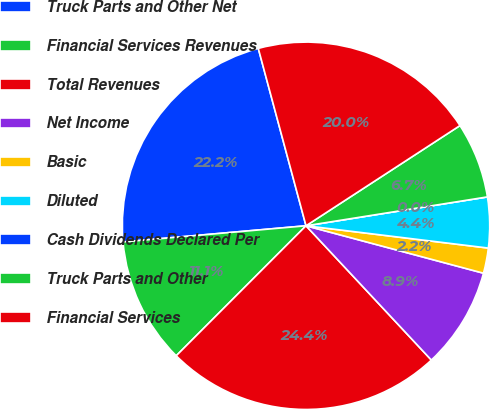Convert chart to OTSL. <chart><loc_0><loc_0><loc_500><loc_500><pie_chart><fcel>Truck Parts and Other Net<fcel>Financial Services Revenues<fcel>Total Revenues<fcel>Net Income<fcel>Basic<fcel>Diluted<fcel>Cash Dividends Declared Per<fcel>Truck Parts and Other<fcel>Financial Services<nl><fcel>22.22%<fcel>11.11%<fcel>24.44%<fcel>8.89%<fcel>2.22%<fcel>4.45%<fcel>0.0%<fcel>6.67%<fcel>20.0%<nl></chart> 